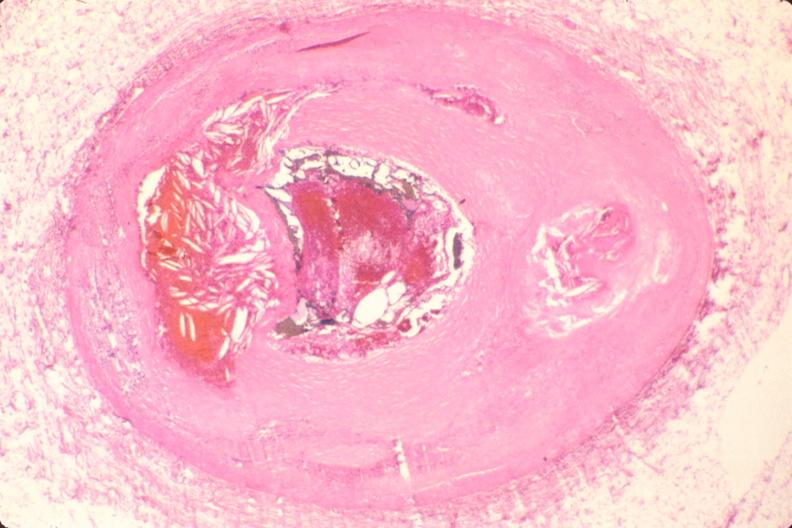what does this image show?
Answer the question using a single word or phrase. Coronary artery atherosclerosis 